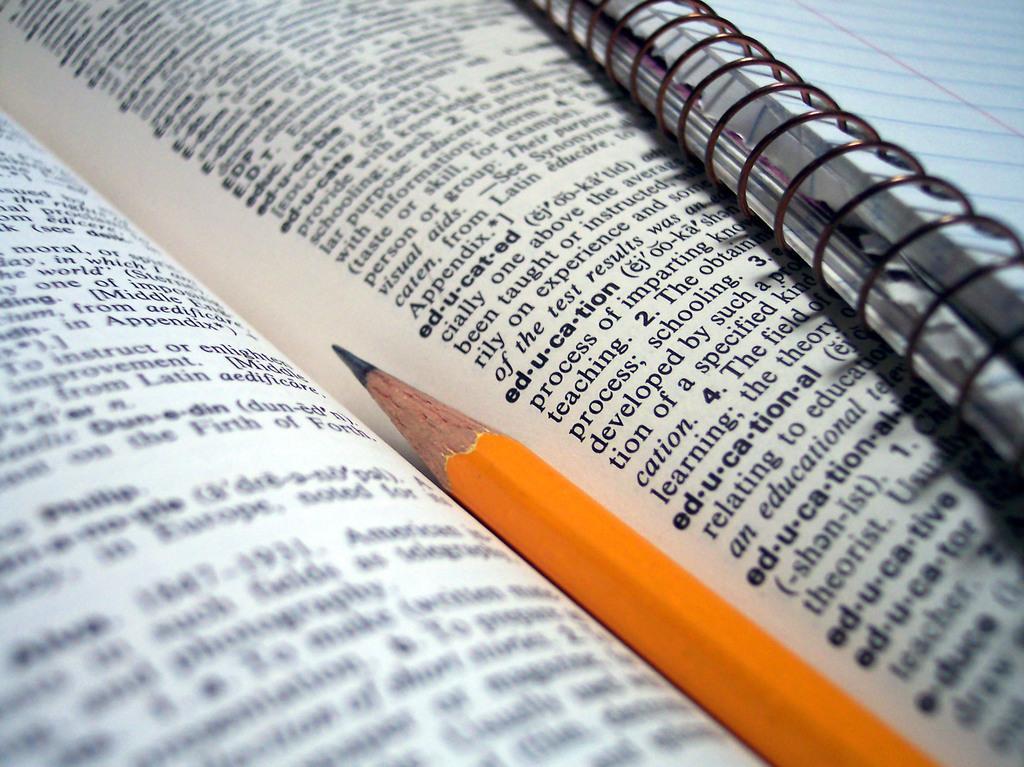In one or two sentences, can you explain what this image depicts? In this image I can see a book and on it I can see something is written, a pencil which is yellow in color and another book. 